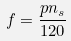<formula> <loc_0><loc_0><loc_500><loc_500>f = \frac { p n _ { s } } { 1 2 0 }</formula> 